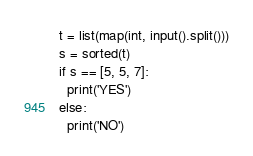Convert code to text. <code><loc_0><loc_0><loc_500><loc_500><_Python_>t = list(map(int, input().split()))
s = sorted(t)
if s == [5, 5, 7]:
  print('YES')
else:
  print('NO')</code> 